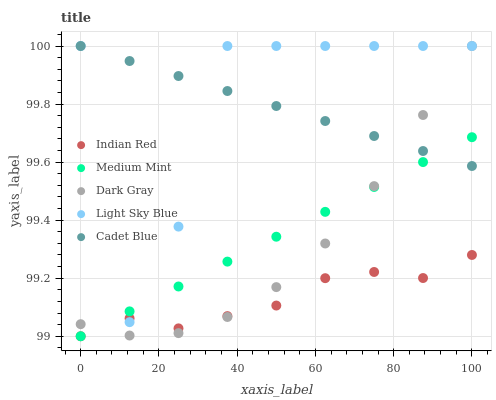Does Indian Red have the minimum area under the curve?
Answer yes or no. Yes. Does Light Sky Blue have the maximum area under the curve?
Answer yes or no. Yes. Does Dark Gray have the minimum area under the curve?
Answer yes or no. No. Does Dark Gray have the maximum area under the curve?
Answer yes or no. No. Is Medium Mint the smoothest?
Answer yes or no. Yes. Is Light Sky Blue the roughest?
Answer yes or no. Yes. Is Dark Gray the smoothest?
Answer yes or no. No. Is Dark Gray the roughest?
Answer yes or no. No. Does Medium Mint have the lowest value?
Answer yes or no. Yes. Does Dark Gray have the lowest value?
Answer yes or no. No. Does Cadet Blue have the highest value?
Answer yes or no. Yes. Does Indian Red have the highest value?
Answer yes or no. No. Is Indian Red less than Cadet Blue?
Answer yes or no. Yes. Is Cadet Blue greater than Indian Red?
Answer yes or no. Yes. Does Light Sky Blue intersect Dark Gray?
Answer yes or no. Yes. Is Light Sky Blue less than Dark Gray?
Answer yes or no. No. Is Light Sky Blue greater than Dark Gray?
Answer yes or no. No. Does Indian Red intersect Cadet Blue?
Answer yes or no. No. 